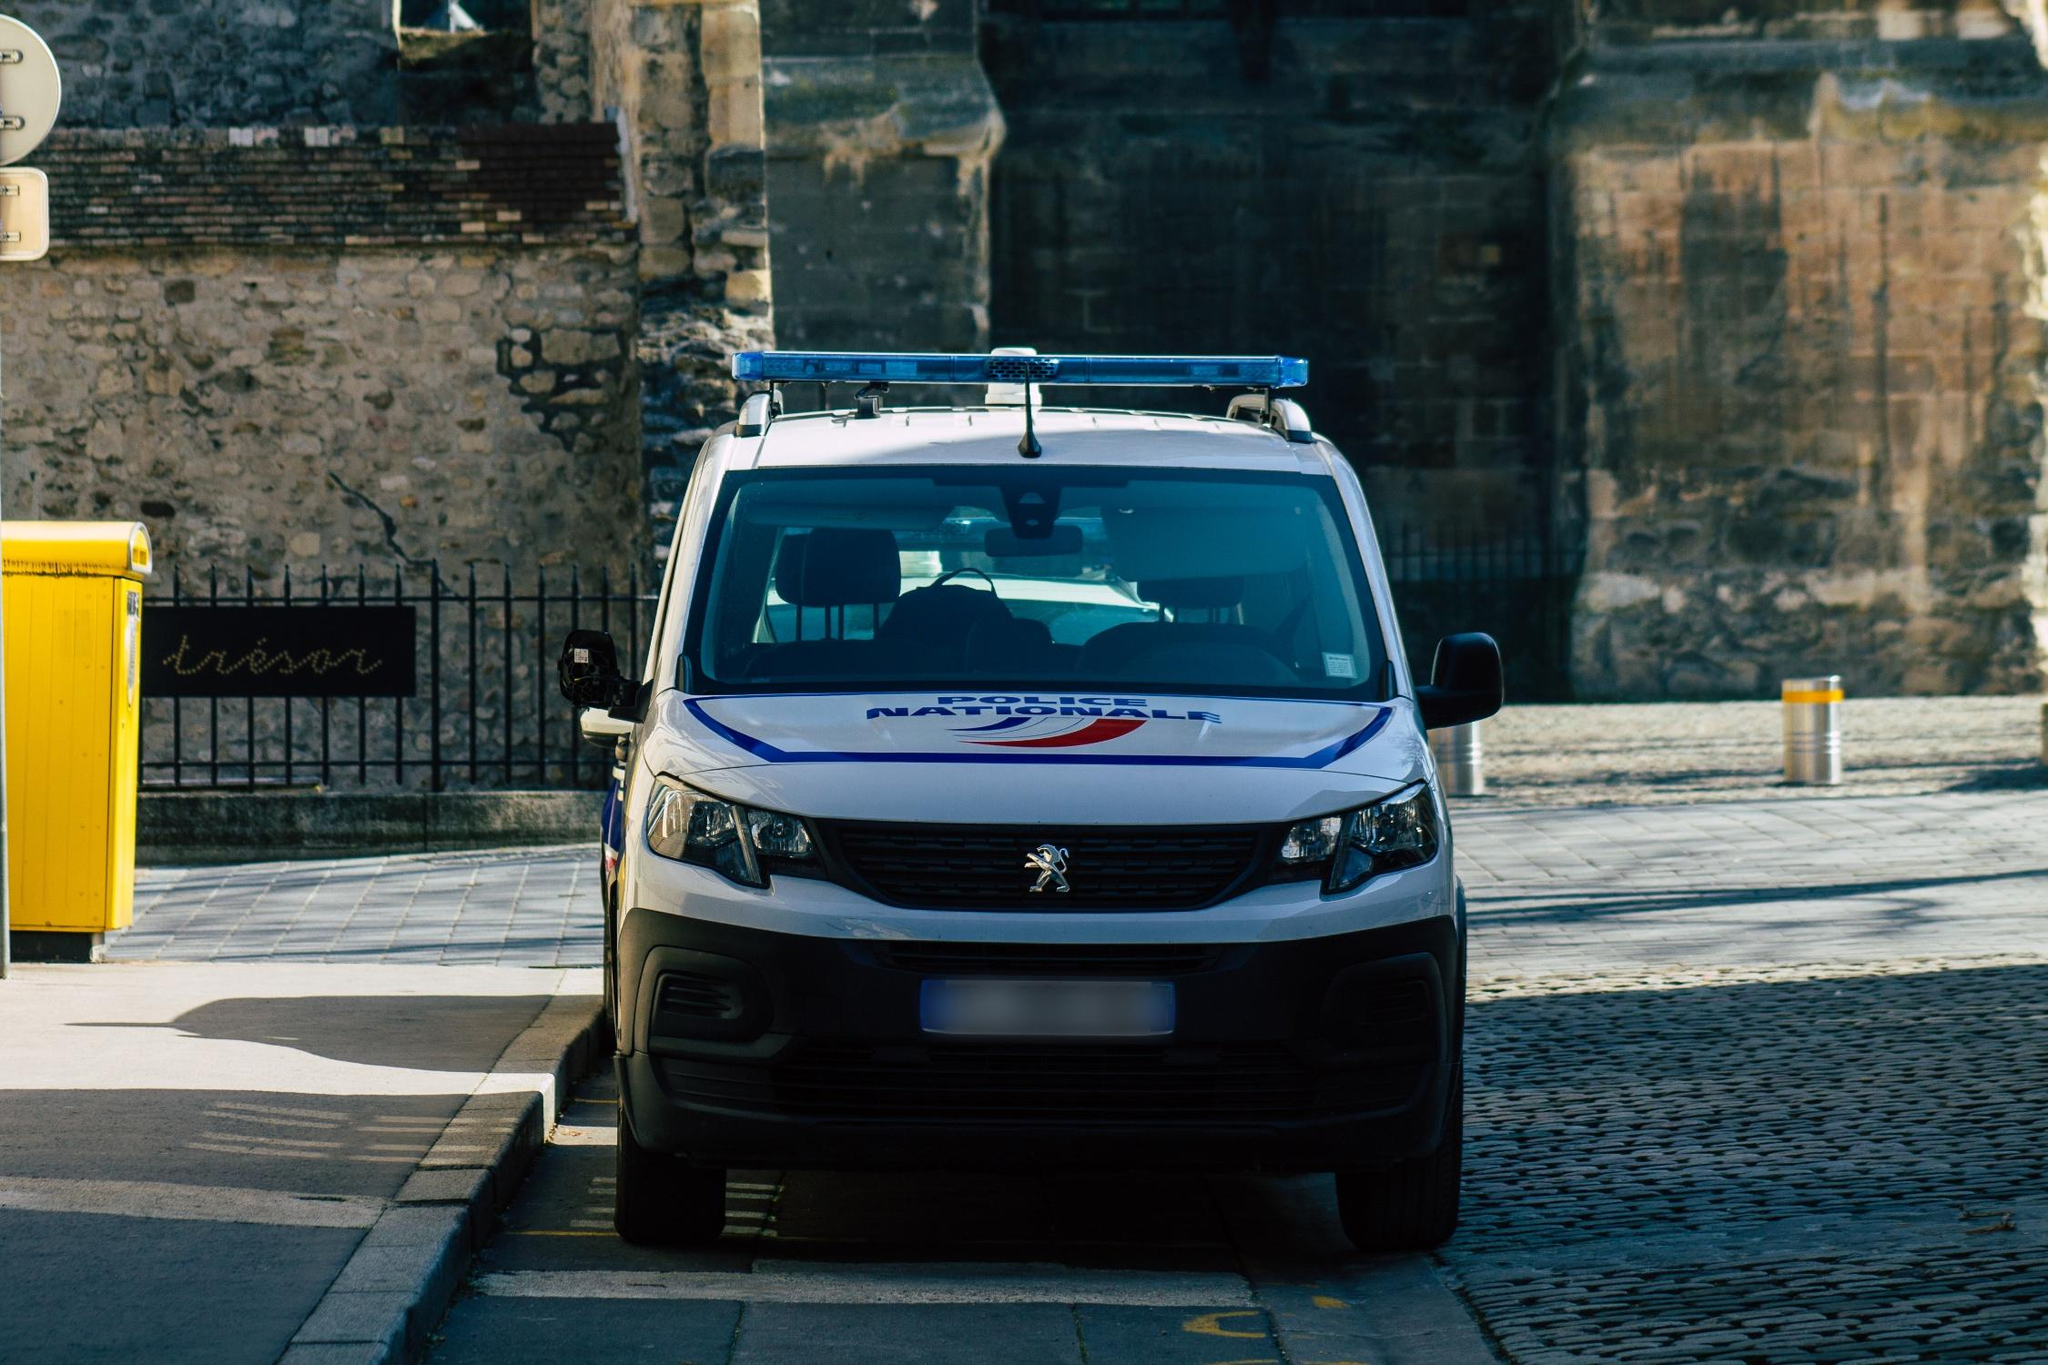What are the indications that this van belongs to a law enforcement agency? The van in the image has several indicators of being used by a law enforcement agency. Firstly, the logo with 'Nationale Politie', which is Dutch for National Police, is prominently displayed. Additionally, the blue beacon on top of the vehicle is commonly used by police vehicles across various countries to signal urgent travel during emergencies. The van's structured and professional design further aligns with what one might expect from a police vehicle. 